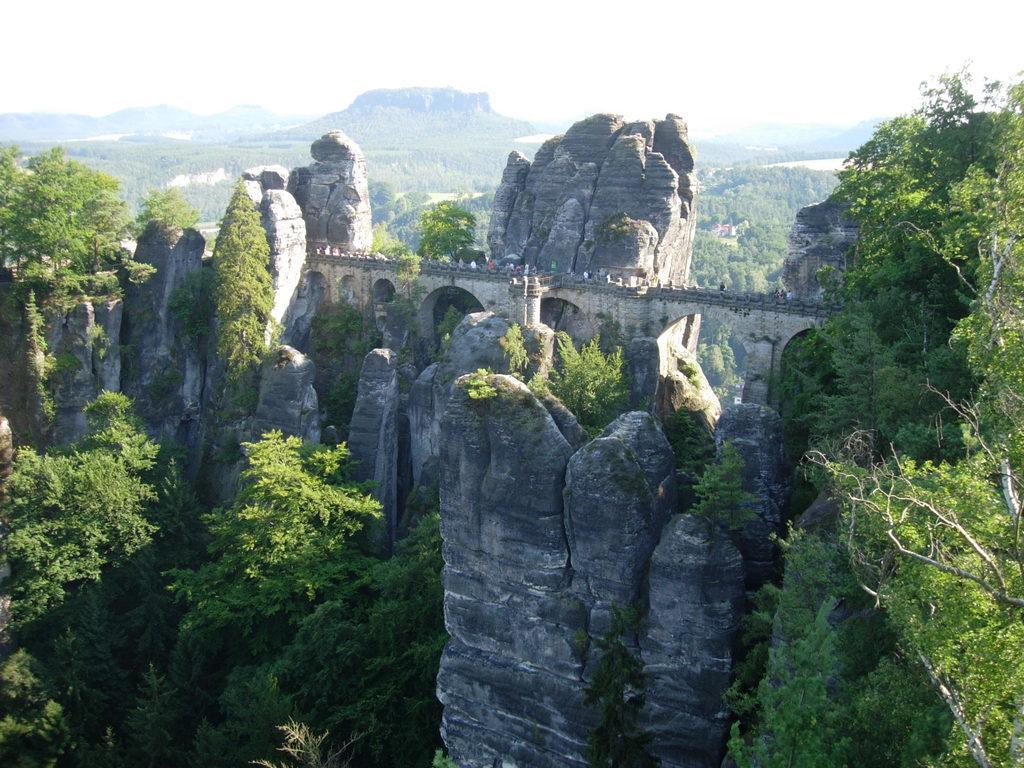In one or two sentences, can you explain what this image depicts? In this image I can see the rocks and trees. In the background I can see the mountains and the white sky. 